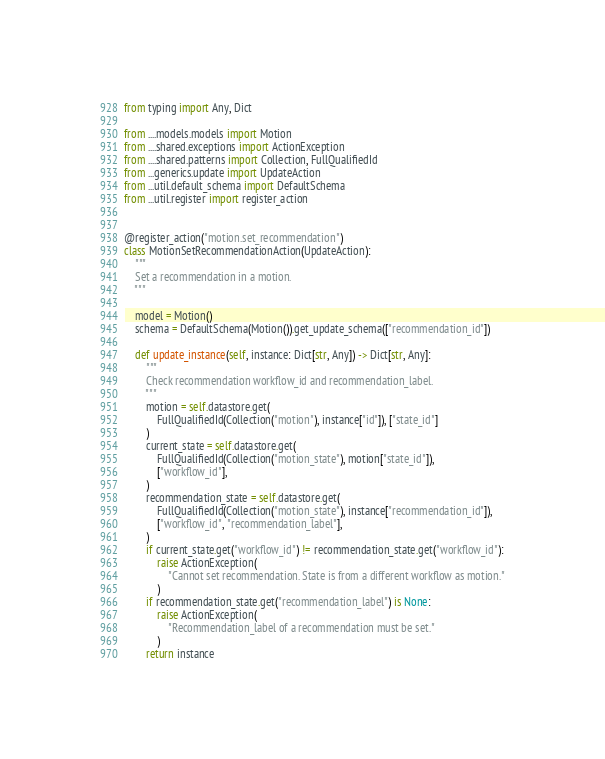<code> <loc_0><loc_0><loc_500><loc_500><_Python_>from typing import Any, Dict

from ....models.models import Motion
from ....shared.exceptions import ActionException
from ....shared.patterns import Collection, FullQualifiedId
from ...generics.update import UpdateAction
from ...util.default_schema import DefaultSchema
from ...util.register import register_action


@register_action("motion.set_recommendation")
class MotionSetRecommendationAction(UpdateAction):
    """
    Set a recommendation in a motion.
    """

    model = Motion()
    schema = DefaultSchema(Motion()).get_update_schema(["recommendation_id"])

    def update_instance(self, instance: Dict[str, Any]) -> Dict[str, Any]:
        """
        Check recommendation workflow_id and recommendation_label.
        """
        motion = self.datastore.get(
            FullQualifiedId(Collection("motion"), instance["id"]), ["state_id"]
        )
        current_state = self.datastore.get(
            FullQualifiedId(Collection("motion_state"), motion["state_id"]),
            ["workflow_id"],
        )
        recommendation_state = self.datastore.get(
            FullQualifiedId(Collection("motion_state"), instance["recommendation_id"]),
            ["workflow_id", "recommendation_label"],
        )
        if current_state.get("workflow_id") != recommendation_state.get("workflow_id"):
            raise ActionException(
                "Cannot set recommendation. State is from a different workflow as motion."
            )
        if recommendation_state.get("recommendation_label") is None:
            raise ActionException(
                "Recommendation_label of a recommendation must be set."
            )
        return instance
</code> 